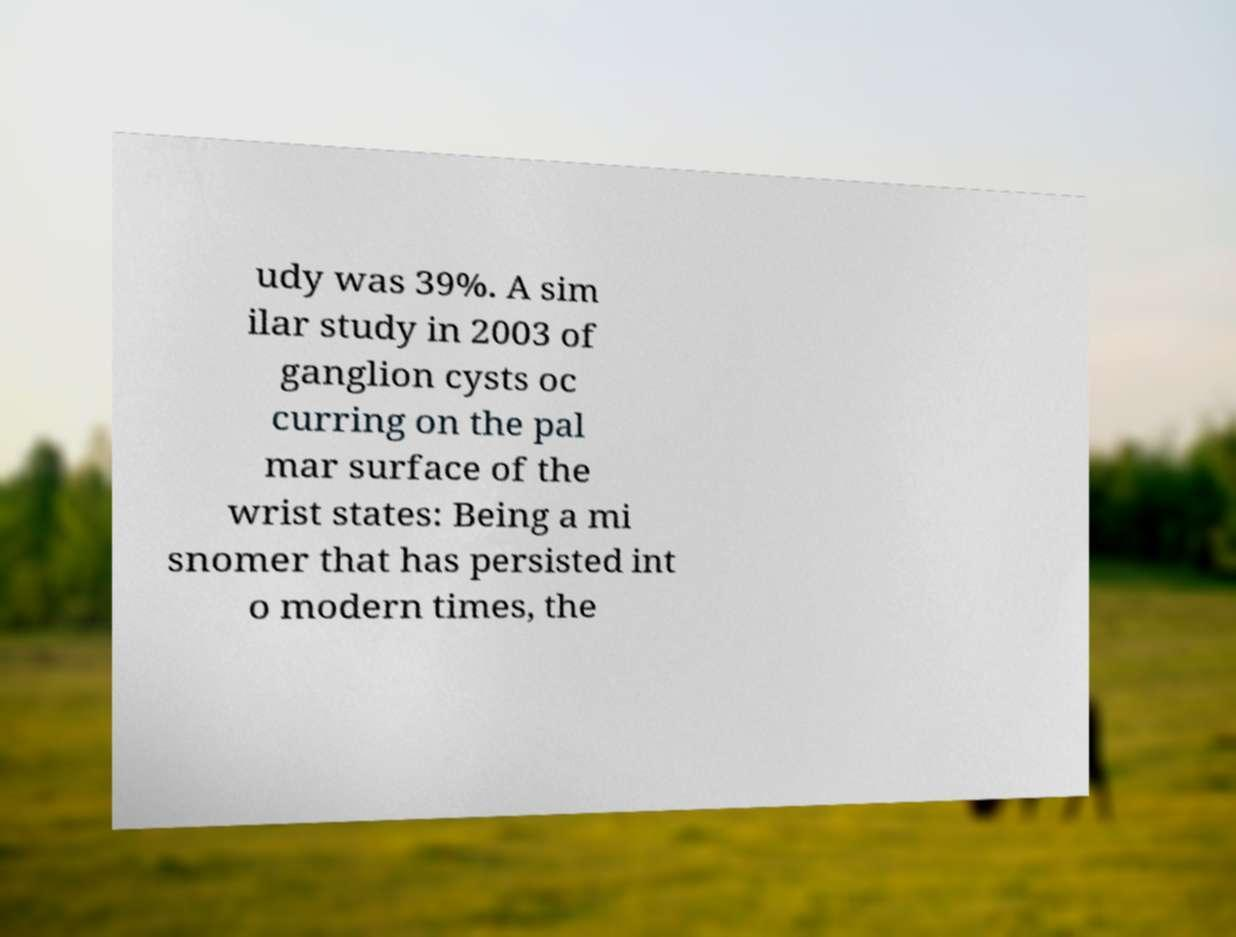Could you extract and type out the text from this image? udy was 39%. A sim ilar study in 2003 of ganglion cysts oc curring on the pal mar surface of the wrist states: Being a mi snomer that has persisted int o modern times, the 